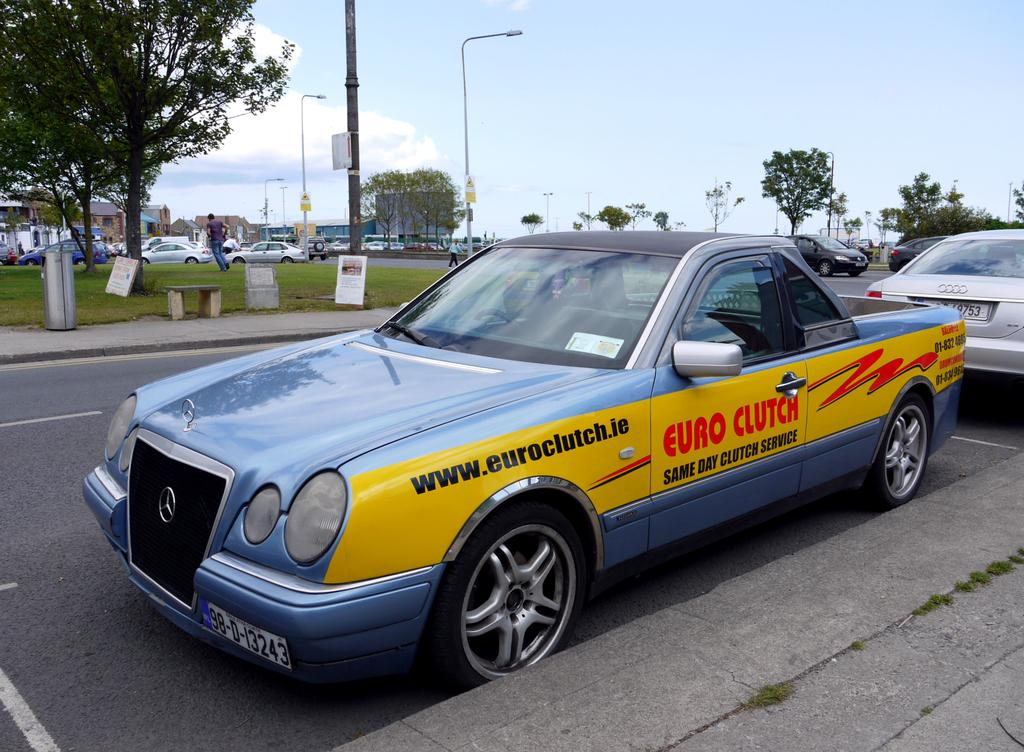<image>
Describe the image concisely. An expensive blue car, whose driver works for Euro Clutch. 